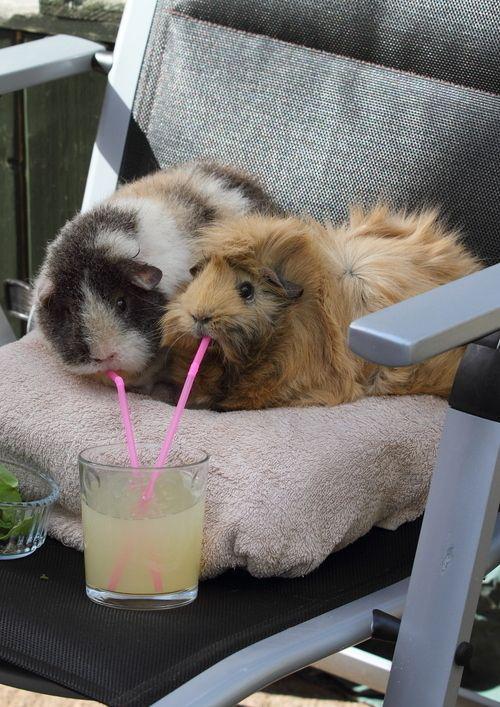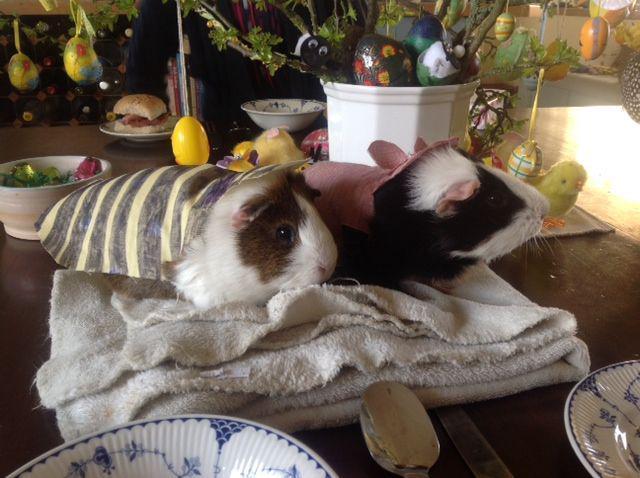The first image is the image on the left, the second image is the image on the right. Given the left and right images, does the statement "There are no more than 4 guinea pigs." hold true? Answer yes or no. Yes. The first image is the image on the left, the second image is the image on the right. For the images shown, is this caption "An image shows a guinea pig having some type of snack." true? Answer yes or no. Yes. The first image is the image on the left, the second image is the image on the right. Examine the images to the left and right. Is the description "At least one image features at least six guinea pigs." accurate? Answer yes or no. No. The first image is the image on the left, the second image is the image on the right. Analyze the images presented: Is the assertion "There are exactly two animals in the image on the left." valid? Answer yes or no. Yes. 